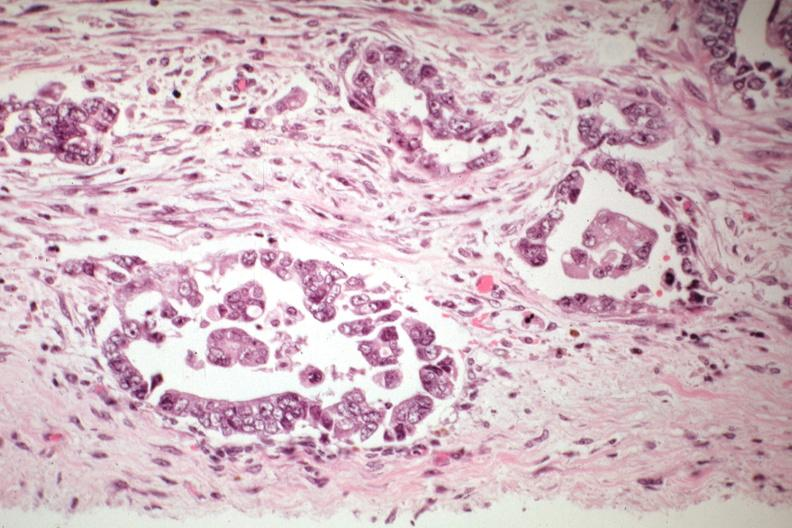s feet present?
Answer the question using a single word or phrase. No 